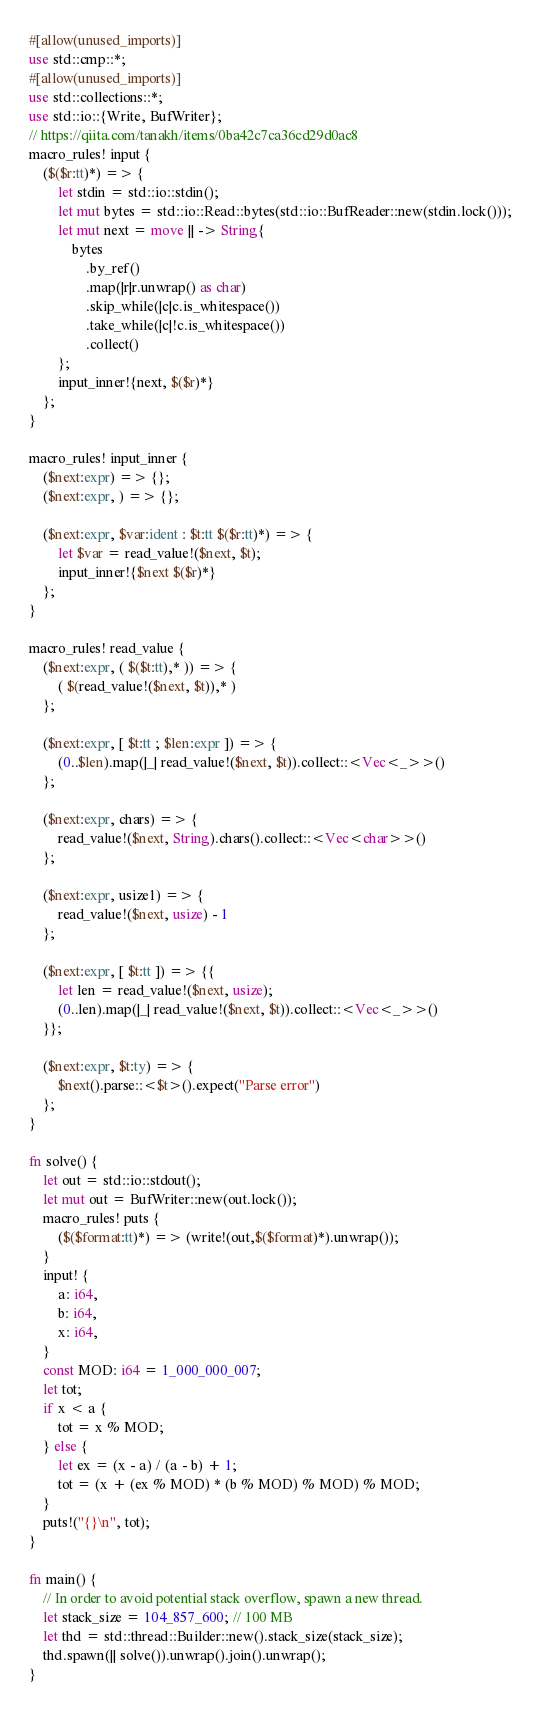<code> <loc_0><loc_0><loc_500><loc_500><_Rust_>#[allow(unused_imports)]
use std::cmp::*;
#[allow(unused_imports)]
use std::collections::*;
use std::io::{Write, BufWriter};
// https://qiita.com/tanakh/items/0ba42c7ca36cd29d0ac8
macro_rules! input {
    ($($r:tt)*) => {
        let stdin = std::io::stdin();
        let mut bytes = std::io::Read::bytes(std::io::BufReader::new(stdin.lock()));
        let mut next = move || -> String{
            bytes
                .by_ref()
                .map(|r|r.unwrap() as char)
                .skip_while(|c|c.is_whitespace())
                .take_while(|c|!c.is_whitespace())
                .collect()
        };
        input_inner!{next, $($r)*}
    };
}

macro_rules! input_inner {
    ($next:expr) => {};
    ($next:expr, ) => {};

    ($next:expr, $var:ident : $t:tt $($r:tt)*) => {
        let $var = read_value!($next, $t);
        input_inner!{$next $($r)*}
    };
}

macro_rules! read_value {
    ($next:expr, ( $($t:tt),* )) => {
        ( $(read_value!($next, $t)),* )
    };

    ($next:expr, [ $t:tt ; $len:expr ]) => {
        (0..$len).map(|_| read_value!($next, $t)).collect::<Vec<_>>()
    };

    ($next:expr, chars) => {
        read_value!($next, String).chars().collect::<Vec<char>>()
    };

    ($next:expr, usize1) => {
        read_value!($next, usize) - 1
    };

    ($next:expr, [ $t:tt ]) => {{
        let len = read_value!($next, usize);
        (0..len).map(|_| read_value!($next, $t)).collect::<Vec<_>>()
    }};

    ($next:expr, $t:ty) => {
        $next().parse::<$t>().expect("Parse error")
    };
}

fn solve() {
    let out = std::io::stdout();
    let mut out = BufWriter::new(out.lock());
    macro_rules! puts {
        ($($format:tt)*) => (write!(out,$($format)*).unwrap());
    }
    input! {
        a: i64,
        b: i64,
        x: i64,
    }
    const MOD: i64 = 1_000_000_007;
    let tot;
    if x < a {
        tot = x % MOD;
    } else {
        let ex = (x - a) / (a - b) + 1;
        tot = (x + (ex % MOD) * (b % MOD) % MOD) % MOD;
    }
    puts!("{}\n", tot);
}

fn main() {
    // In order to avoid potential stack overflow, spawn a new thread.
    let stack_size = 104_857_600; // 100 MB
    let thd = std::thread::Builder::new().stack_size(stack_size);
    thd.spawn(|| solve()).unwrap().join().unwrap();
}

</code> 